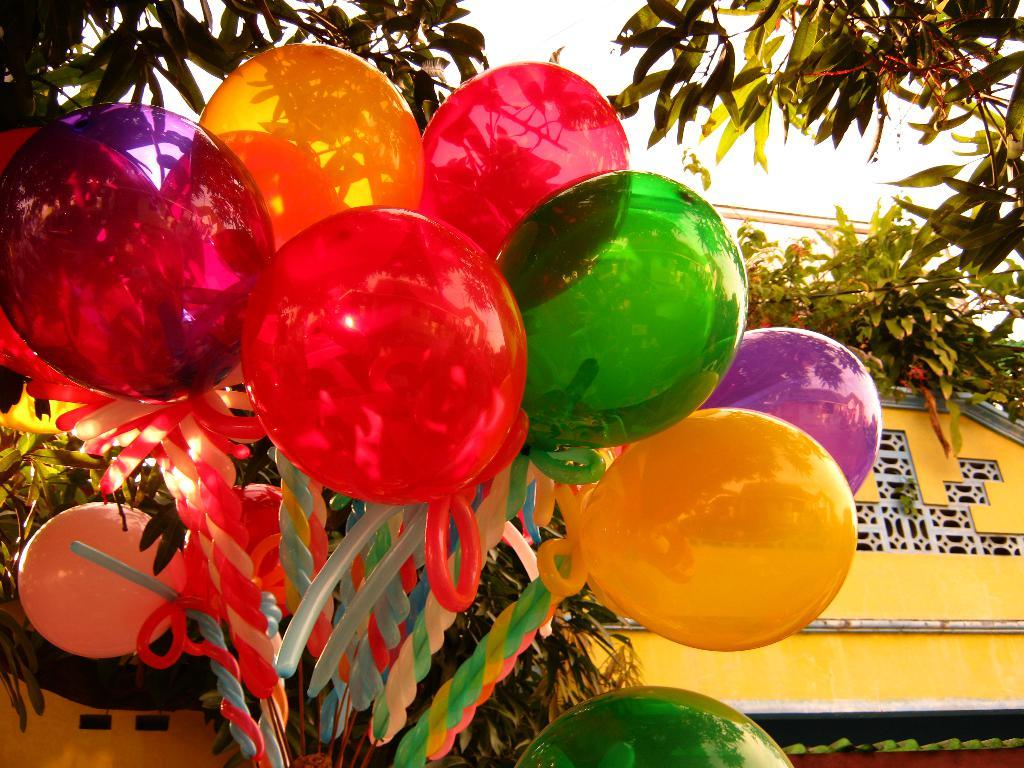What objects are present in the image? There are balloons and leaves visible in the image. Can you describe the background of the image? There is a building in the background of the image. What type of collar can be seen on the leaves in the image? There is no collar present on the leaves in the image. What color are the underwear of the balloons in the image? Balloons do not wear underwear, so this question cannot be answered. 